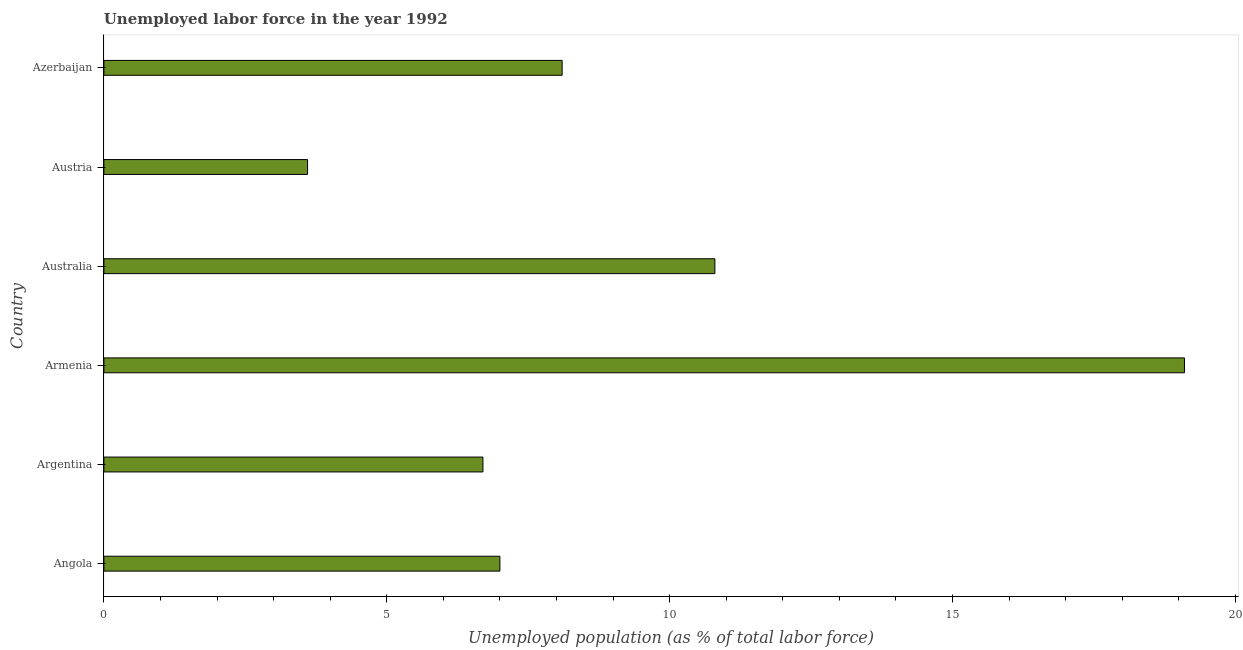Does the graph contain any zero values?
Provide a short and direct response. No. Does the graph contain grids?
Keep it short and to the point. No. What is the title of the graph?
Keep it short and to the point. Unemployed labor force in the year 1992. What is the label or title of the X-axis?
Provide a short and direct response. Unemployed population (as % of total labor force). What is the total unemployed population in Australia?
Your answer should be compact. 10.8. Across all countries, what is the maximum total unemployed population?
Provide a succinct answer. 19.1. Across all countries, what is the minimum total unemployed population?
Keep it short and to the point. 3.6. In which country was the total unemployed population maximum?
Your answer should be compact. Armenia. What is the sum of the total unemployed population?
Make the answer very short. 55.3. What is the difference between the total unemployed population in Angola and Armenia?
Make the answer very short. -12.1. What is the average total unemployed population per country?
Your answer should be compact. 9.22. What is the median total unemployed population?
Make the answer very short. 7.55. In how many countries, is the total unemployed population greater than 4 %?
Offer a very short reply. 5. What is the ratio of the total unemployed population in Angola to that in Azerbaijan?
Your response must be concise. 0.86. Is the total unemployed population in Argentina less than that in Austria?
Your answer should be very brief. No. Is the difference between the total unemployed population in Angola and Argentina greater than the difference between any two countries?
Offer a terse response. No. What is the difference between the highest and the second highest total unemployed population?
Give a very brief answer. 8.3. What is the difference between the highest and the lowest total unemployed population?
Provide a short and direct response. 15.5. How many countries are there in the graph?
Provide a short and direct response. 6. What is the Unemployed population (as % of total labor force) of Argentina?
Your response must be concise. 6.7. What is the Unemployed population (as % of total labor force) in Armenia?
Provide a short and direct response. 19.1. What is the Unemployed population (as % of total labor force) in Australia?
Give a very brief answer. 10.8. What is the Unemployed population (as % of total labor force) in Austria?
Give a very brief answer. 3.6. What is the Unemployed population (as % of total labor force) of Azerbaijan?
Ensure brevity in your answer.  8.1. What is the difference between the Unemployed population (as % of total labor force) in Angola and Armenia?
Your answer should be very brief. -12.1. What is the difference between the Unemployed population (as % of total labor force) in Argentina and Armenia?
Give a very brief answer. -12.4. What is the difference between the Unemployed population (as % of total labor force) in Argentina and Australia?
Provide a succinct answer. -4.1. What is the difference between the Unemployed population (as % of total labor force) in Argentina and Azerbaijan?
Your answer should be very brief. -1.4. What is the difference between the Unemployed population (as % of total labor force) in Armenia and Austria?
Your answer should be compact. 15.5. What is the difference between the Unemployed population (as % of total labor force) in Australia and Austria?
Offer a very short reply. 7.2. What is the ratio of the Unemployed population (as % of total labor force) in Angola to that in Argentina?
Make the answer very short. 1.04. What is the ratio of the Unemployed population (as % of total labor force) in Angola to that in Armenia?
Offer a very short reply. 0.37. What is the ratio of the Unemployed population (as % of total labor force) in Angola to that in Australia?
Your answer should be very brief. 0.65. What is the ratio of the Unemployed population (as % of total labor force) in Angola to that in Austria?
Keep it short and to the point. 1.94. What is the ratio of the Unemployed population (as % of total labor force) in Angola to that in Azerbaijan?
Make the answer very short. 0.86. What is the ratio of the Unemployed population (as % of total labor force) in Argentina to that in Armenia?
Your response must be concise. 0.35. What is the ratio of the Unemployed population (as % of total labor force) in Argentina to that in Australia?
Ensure brevity in your answer.  0.62. What is the ratio of the Unemployed population (as % of total labor force) in Argentina to that in Austria?
Provide a succinct answer. 1.86. What is the ratio of the Unemployed population (as % of total labor force) in Argentina to that in Azerbaijan?
Make the answer very short. 0.83. What is the ratio of the Unemployed population (as % of total labor force) in Armenia to that in Australia?
Provide a succinct answer. 1.77. What is the ratio of the Unemployed population (as % of total labor force) in Armenia to that in Austria?
Make the answer very short. 5.31. What is the ratio of the Unemployed population (as % of total labor force) in Armenia to that in Azerbaijan?
Make the answer very short. 2.36. What is the ratio of the Unemployed population (as % of total labor force) in Australia to that in Azerbaijan?
Your response must be concise. 1.33. What is the ratio of the Unemployed population (as % of total labor force) in Austria to that in Azerbaijan?
Give a very brief answer. 0.44. 